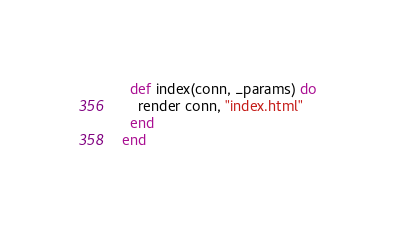Convert code to text. <code><loc_0><loc_0><loc_500><loc_500><_Elixir_>
  def index(conn, _params) do
    render conn, "index.html"
  end
end
</code> 